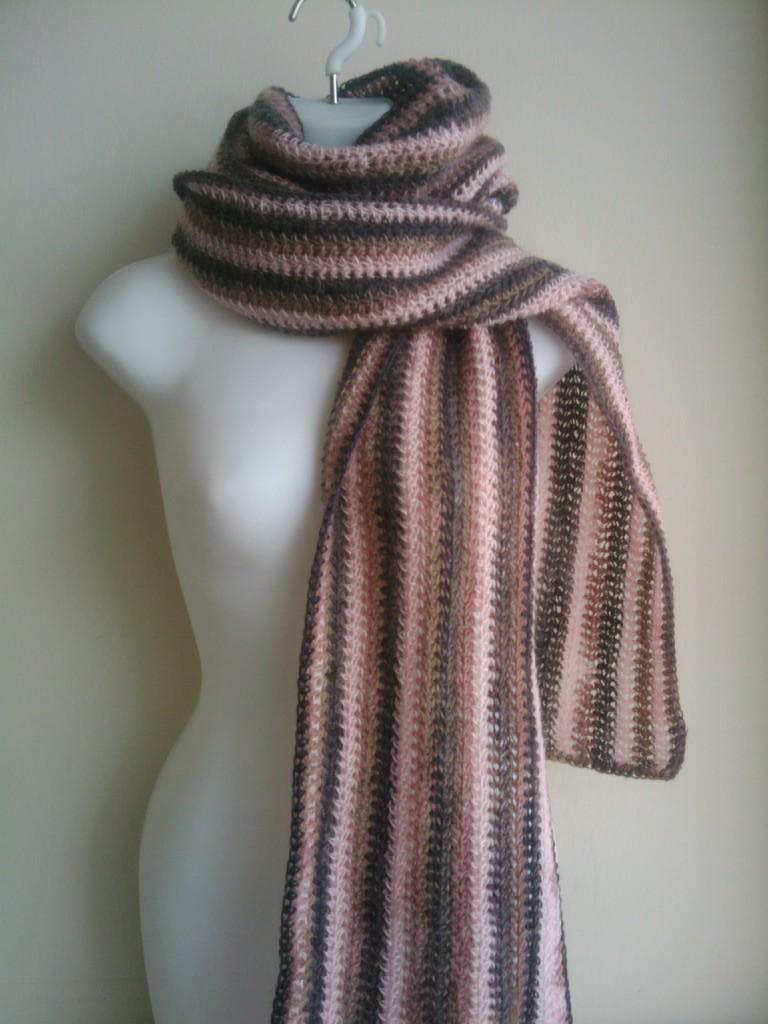What is the main subject of the image? There is a female mannequin in the image. What is the color of the mannequin? The mannequin is white in color. What accessory is the mannequin wearing? There is a stole around the neck of the mannequin. What type of unit is located near the cemetery in the image? There is no cemetery or unit present in the image; it only features a female mannequin with a stole around its neck. 